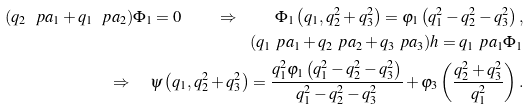Convert formula to latex. <formula><loc_0><loc_0><loc_500><loc_500>( q _ { 2 } \ p a _ { 1 } + q _ { 1 } \ p a _ { 2 } ) \Phi _ { 1 } = 0 \quad \Rightarrow \quad \Phi _ { 1 } \left ( q _ { 1 } , q _ { 2 } ^ { 2 } + q _ { 3 } ^ { 2 } \right ) = \varphi _ { 1 } \left ( q _ { 1 } ^ { 2 } - q _ { 2 } ^ { 2 } - q _ { 3 } ^ { 2 } \right ) , \\ ( q _ { 1 } \ p a _ { 1 } + q _ { 2 } \ p a _ { 2 } + q _ { 3 } \ p a _ { 3 } ) h = q _ { 1 } \ p a _ { 1 } \Phi _ { 1 } \\ \Rightarrow \quad \psi \left ( q _ { 1 } , q _ { 2 } ^ { 2 } + q _ { 3 } ^ { 2 } \right ) = \frac { q _ { 1 } ^ { 2 } \varphi _ { 1 } \left ( q _ { 1 } ^ { 2 } - q _ { 2 } ^ { 2 } - q _ { 3 } ^ { 2 } \right ) } { q _ { 1 } ^ { 2 } - q _ { 2 } ^ { 2 } - q _ { 3 } ^ { 2 } } + \varphi _ { 3 } \left ( \frac { q _ { 2 } ^ { 2 } + q _ { 3 } ^ { 2 } } { q _ { 1 } ^ { 2 } } \right ) .</formula> 